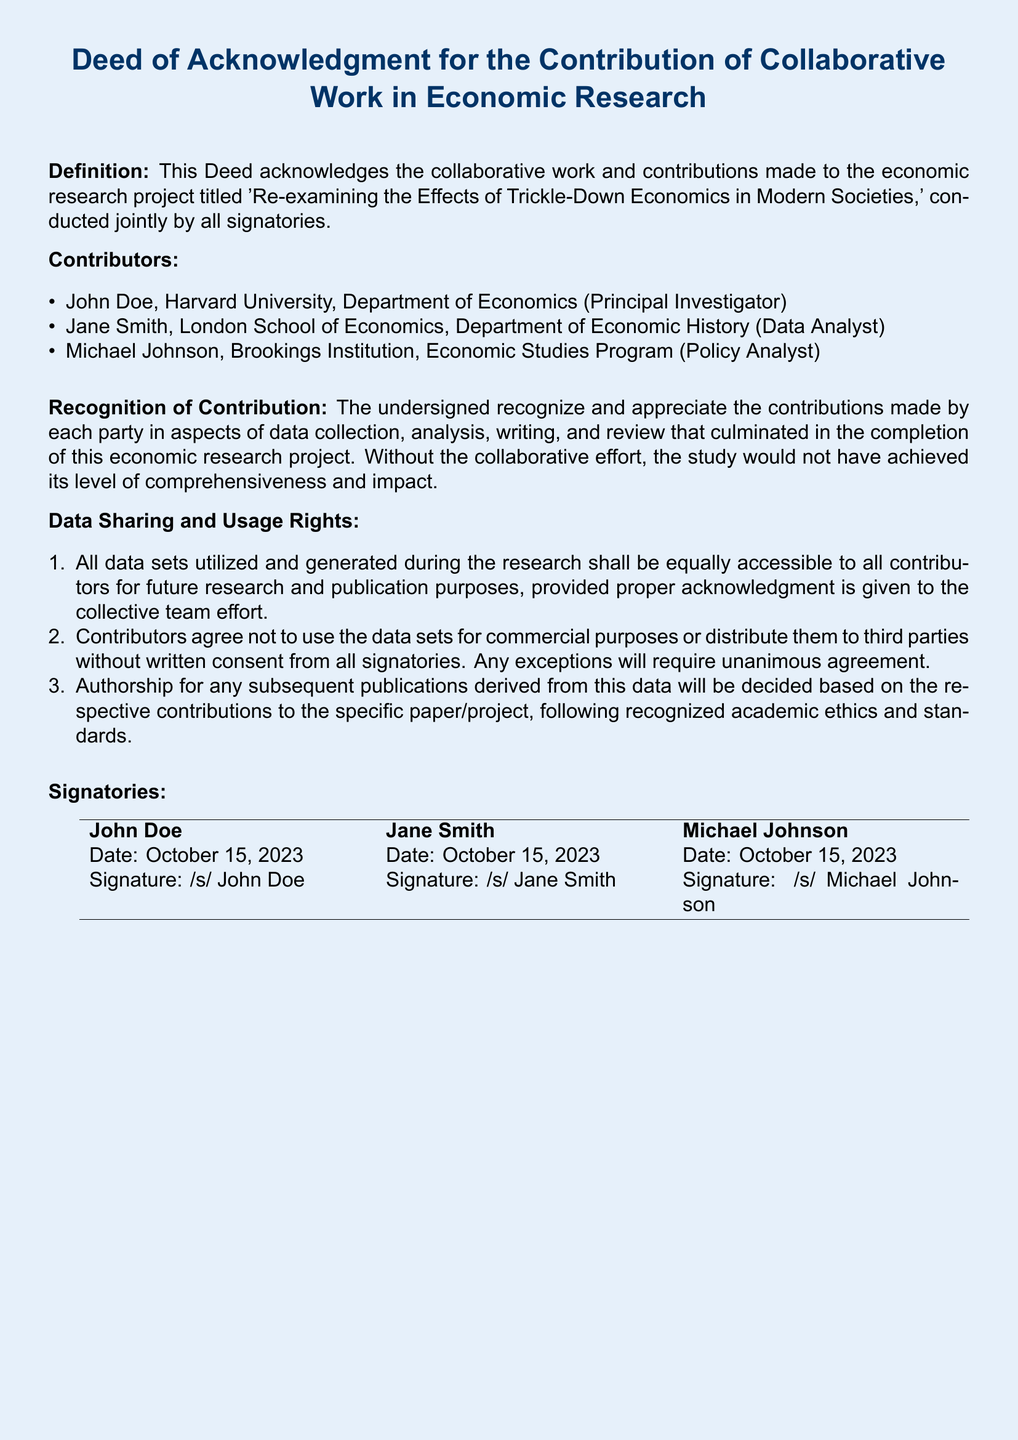What is the title of the research project? The title of the research project is specified in the deed, summarizing its focus on trickle-down economics.
Answer: Re-examining the Effects of Trickle-Down Economics in Modern Societies Who is the Principal Investigator? The document lists the contributors along with their roles, identifying John Doe as the Principal Investigator.
Answer: John Doe What is the date of signing for the deed? The signing date is provided for all signatories in the deed.
Answer: October 15, 2023 How many contributors are recognized in the document? The contribution section details the number of individuals recognized in the collaborative work.
Answer: Three What are the usage rights for data sets according to the deed? The deed specifies that data sets shall be equally accessible to all contributors for future purposes.
Answer: Equally accessible Can contributors use the data sets for commercial purposes? The deed explicitly mentions restrictions on the use of data sets for commercial purposes.
Answer: No What is required for distributing data sets to third parties? The document states that any distribution requires written consent from all signatories.
Answer: Written consent How will authorship for future publications be decided? The deed outlines that authorship decisions will be based on respective contributions following recognized academic ethics.
Answer: Based on contributions What is the color of the page in the rendered document? The document specifies a light blue color for the page background.
Answer: Light blue 